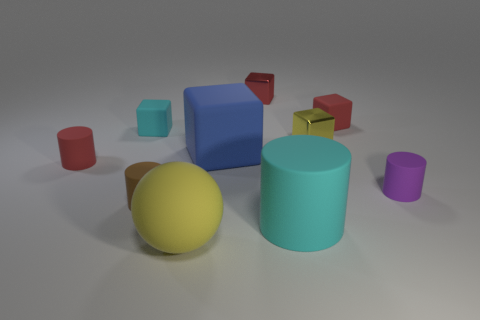Do the red object that is on the left side of the big yellow object and the tiny cylinder that is right of the big block have the same material? While both the red object on the left of the yellow sphere and the tiny cylinder to the right of the large blue block appear to have similar reflective qualities suggesting a potential similarity in material, it's not possible to determine with certainty that they are made of the same material without additional context or information. However, based on the visual indicators, we can tentatively say they might be composed of a material with a similar finish. 